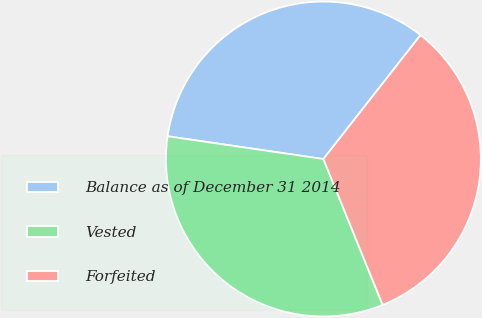<chart> <loc_0><loc_0><loc_500><loc_500><pie_chart><fcel>Balance as of December 31 2014<fcel>Vested<fcel>Forfeited<nl><fcel>33.27%<fcel>33.45%<fcel>33.28%<nl></chart> 